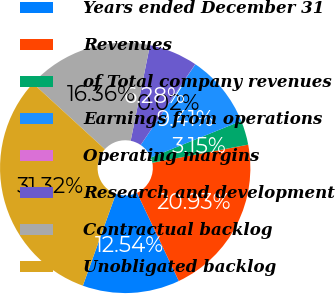Convert chart to OTSL. <chart><loc_0><loc_0><loc_500><loc_500><pie_chart><fcel>Years ended December 31<fcel>Revenues<fcel>of Total company revenues<fcel>Earnings from operations<fcel>Operating margins<fcel>Research and development<fcel>Contractual backlog<fcel>Unobligated backlog<nl><fcel>12.54%<fcel>20.93%<fcel>3.15%<fcel>9.41%<fcel>0.02%<fcel>6.28%<fcel>16.36%<fcel>31.32%<nl></chart> 